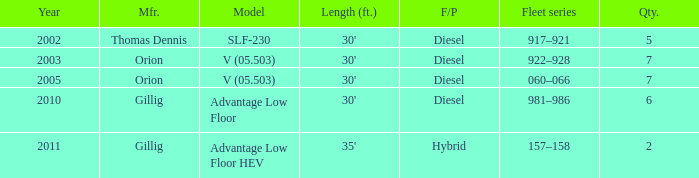Name the fleet series with a quantity of 5 917–921. 